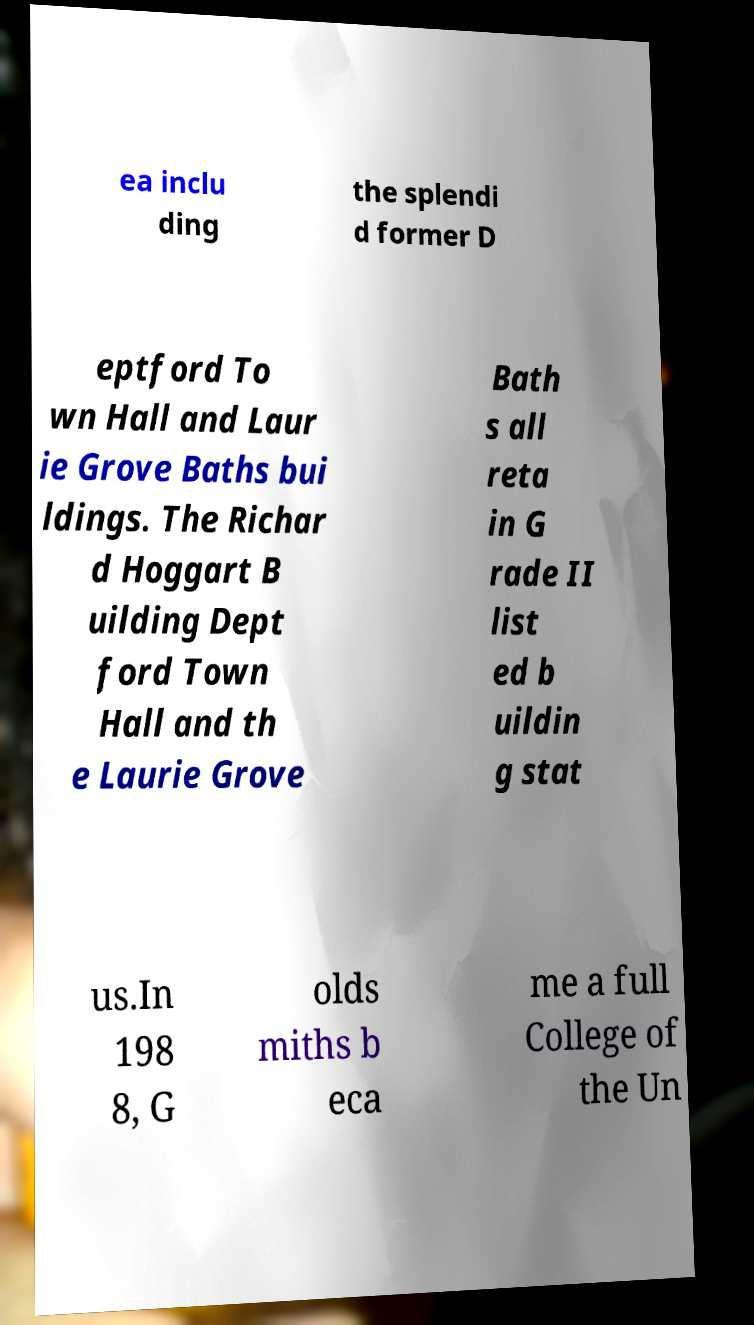I need the written content from this picture converted into text. Can you do that? ea inclu ding the splendi d former D eptford To wn Hall and Laur ie Grove Baths bui ldings. The Richar d Hoggart B uilding Dept ford Town Hall and th e Laurie Grove Bath s all reta in G rade II list ed b uildin g stat us.In 198 8, G olds miths b eca me a full College of the Un 